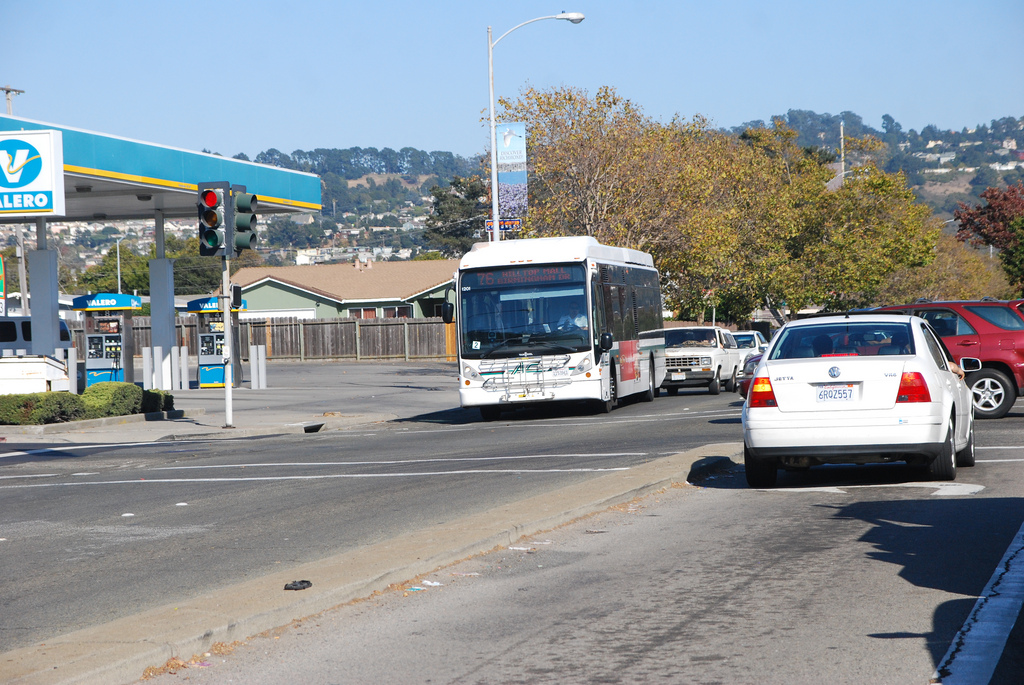What color does the fence have? The fence, which is made of wood, has a natural light to medium brown tone, typical of wooden outdoor structures. 